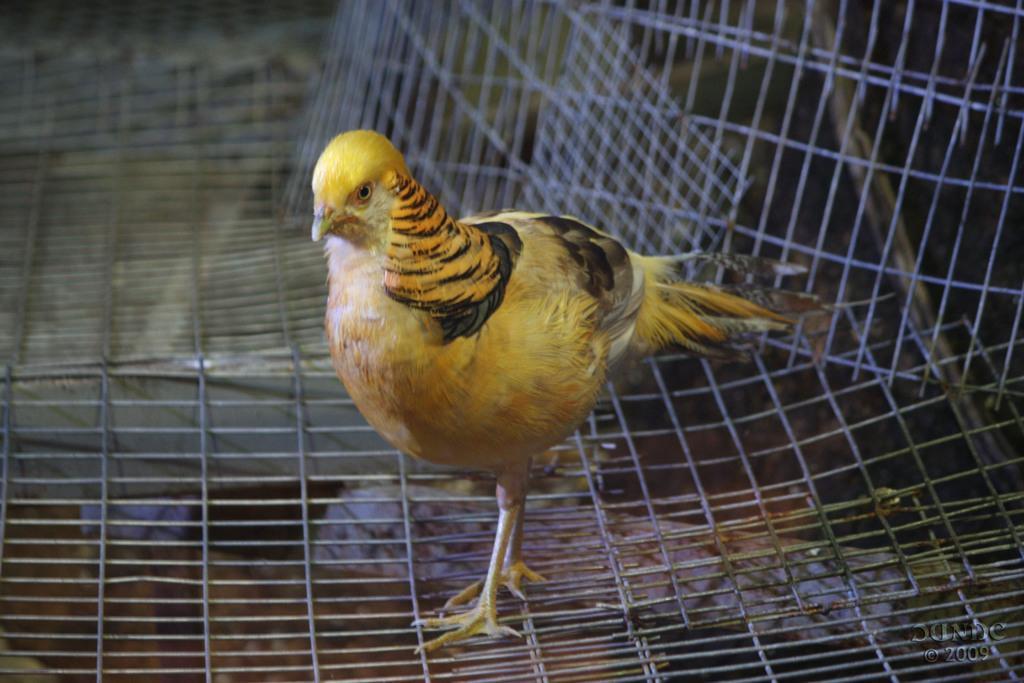How would you summarize this image in a sentence or two? In this picture there is a yellow color hen which is standing on the steel fencing. At the bottom I can see the floor. In the bottom right corner there is a watermark. 